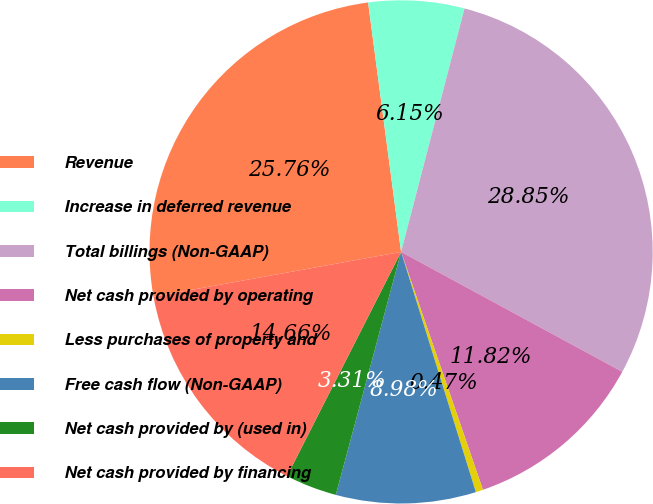Convert chart. <chart><loc_0><loc_0><loc_500><loc_500><pie_chart><fcel>Revenue<fcel>Increase in deferred revenue<fcel>Total billings (Non-GAAP)<fcel>Net cash provided by operating<fcel>Less purchases of property and<fcel>Free cash flow (Non-GAAP)<fcel>Net cash provided by (used in)<fcel>Net cash provided by financing<nl><fcel>25.76%<fcel>6.15%<fcel>28.85%<fcel>11.82%<fcel>0.47%<fcel>8.98%<fcel>3.31%<fcel>14.66%<nl></chart> 